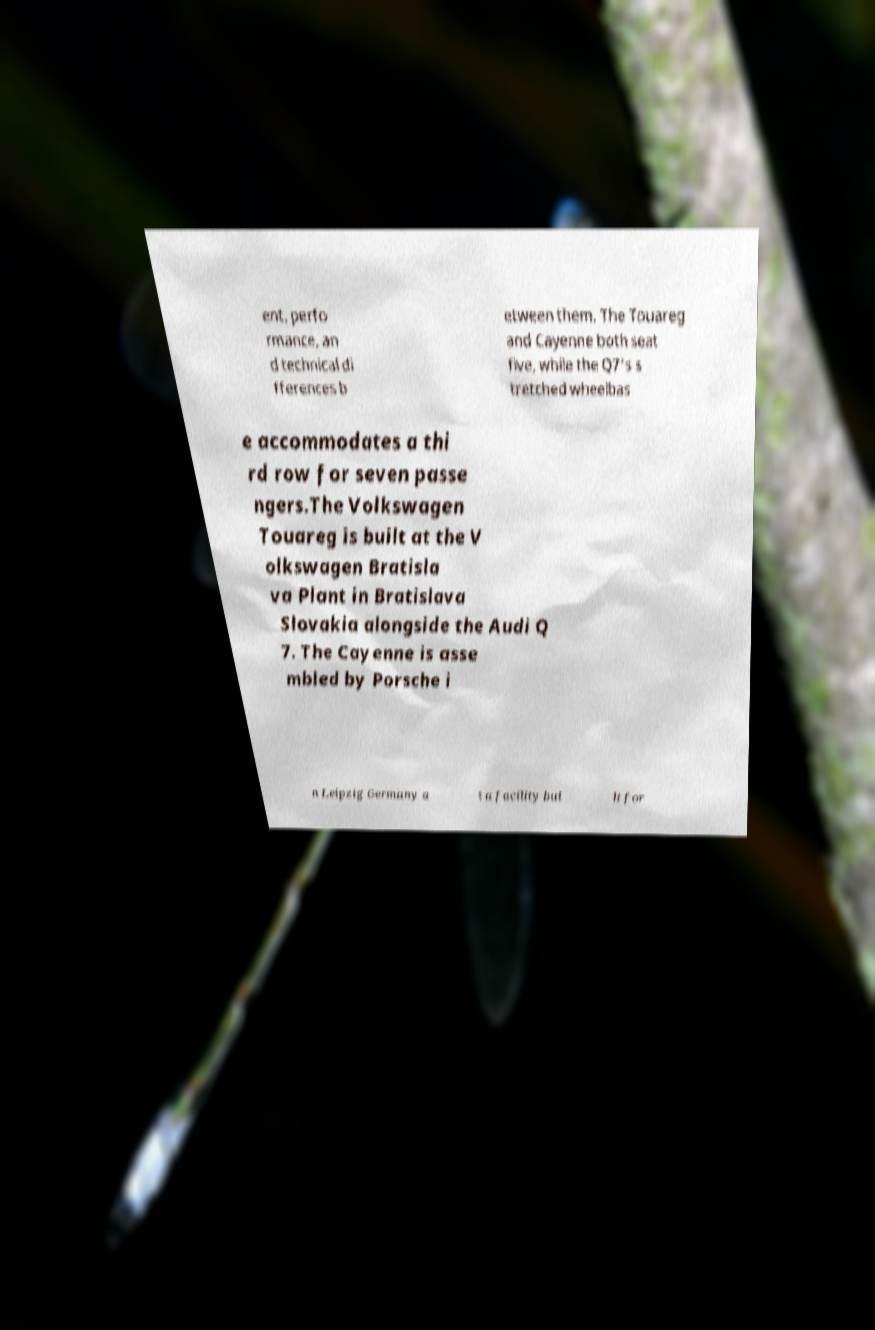There's text embedded in this image that I need extracted. Can you transcribe it verbatim? ent, perfo rmance, an d technical di fferences b etween them. The Touareg and Cayenne both seat five, while the Q7's s tretched wheelbas e accommodates a thi rd row for seven passe ngers.The Volkswagen Touareg is built at the V olkswagen Bratisla va Plant in Bratislava Slovakia alongside the Audi Q 7. The Cayenne is asse mbled by Porsche i n Leipzig Germany a t a facility bui lt for 